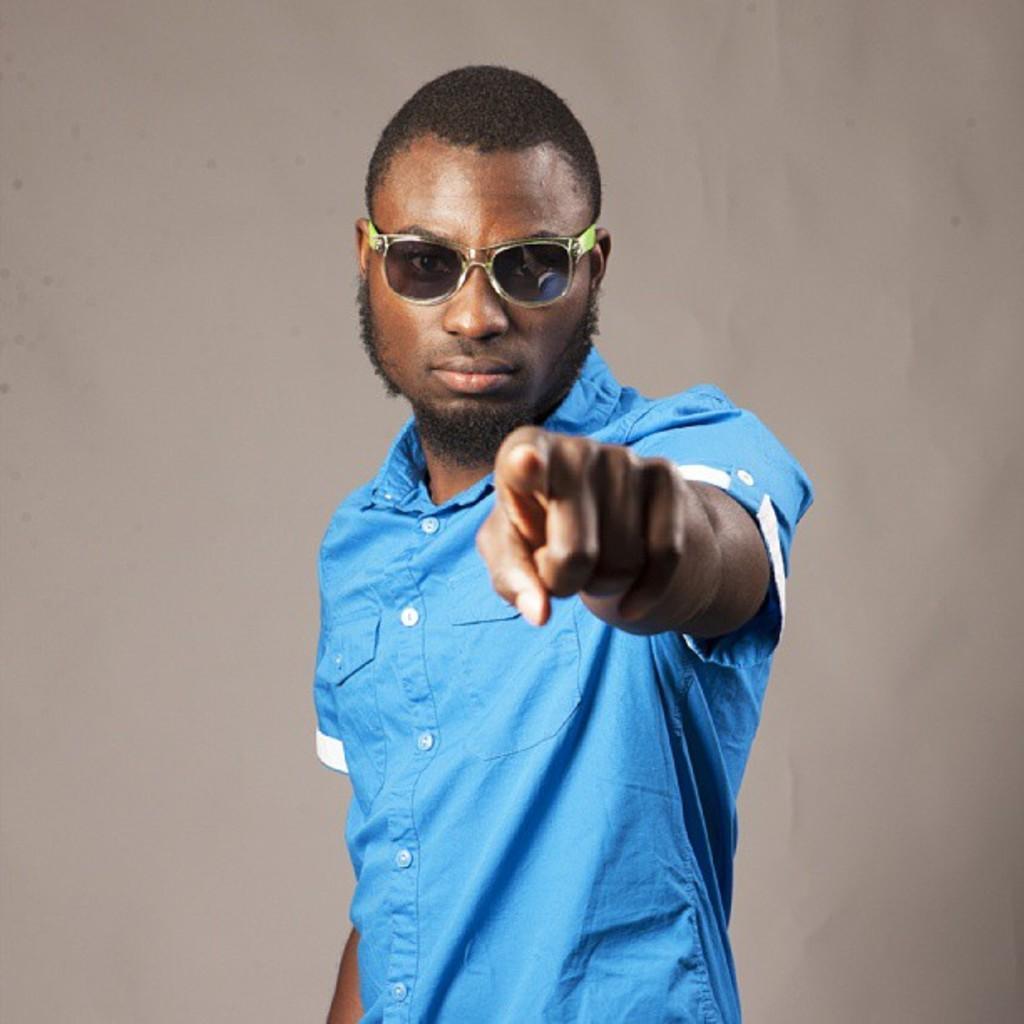Please provide a concise description of this image. This image is taken indoors. In the background there is a wall. In the middle of the image there is a man. He has worn a blue shirt and google. 